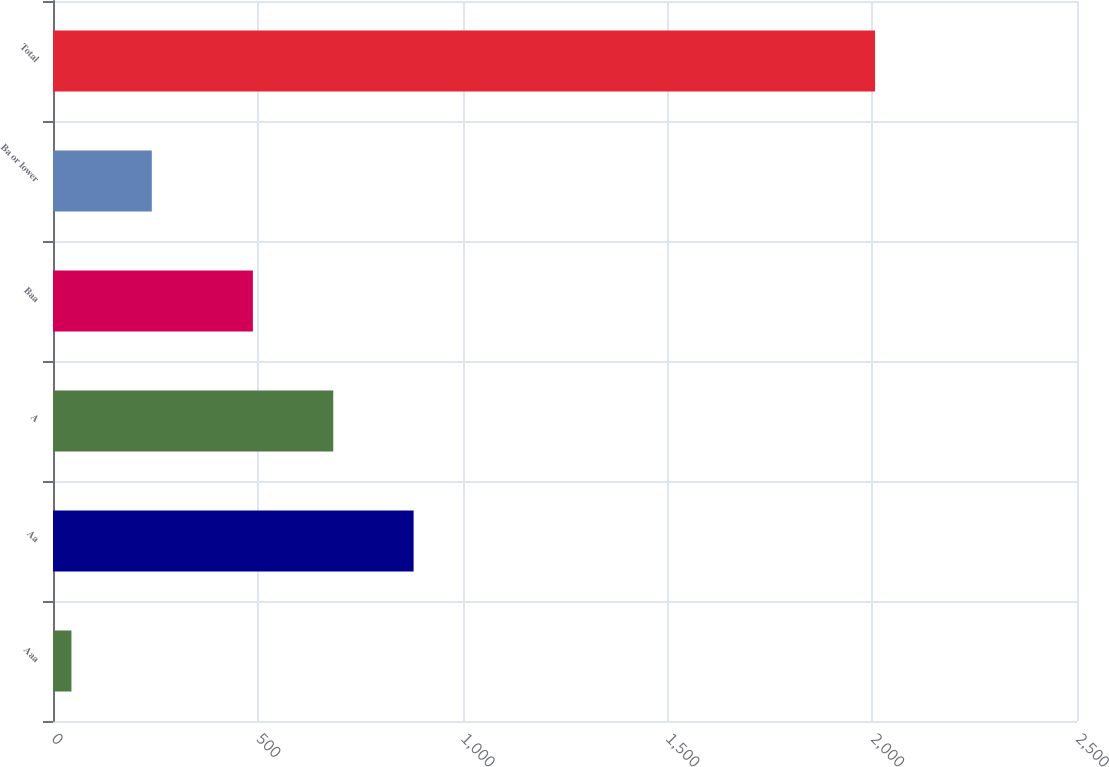Convert chart to OTSL. <chart><loc_0><loc_0><loc_500><loc_500><bar_chart><fcel>Aaa<fcel>Aa<fcel>A<fcel>Baa<fcel>Ba or lower<fcel>Total<nl><fcel>45<fcel>880.4<fcel>684.2<fcel>488<fcel>241.2<fcel>2007<nl></chart> 